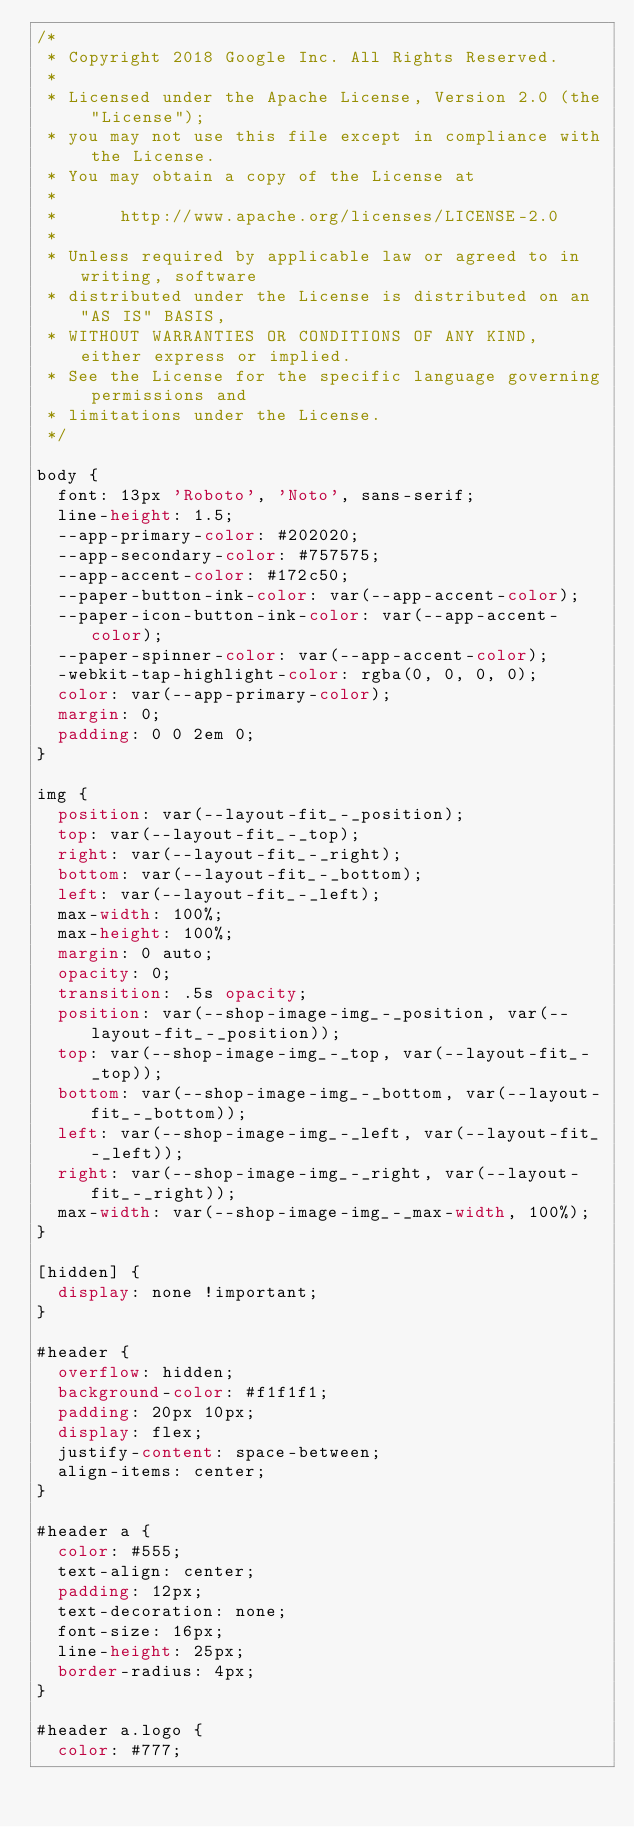<code> <loc_0><loc_0><loc_500><loc_500><_CSS_>/*
 * Copyright 2018 Google Inc. All Rights Reserved.
 *
 * Licensed under the Apache License, Version 2.0 (the "License");
 * you may not use this file except in compliance with the License.
 * You may obtain a copy of the License at
 *
 *      http://www.apache.org/licenses/LICENSE-2.0
 *
 * Unless required by applicable law or agreed to in writing, software
 * distributed under the License is distributed on an "AS IS" BASIS,
 * WITHOUT WARRANTIES OR CONDITIONS OF ANY KIND, either express or implied.
 * See the License for the specific language governing permissions and
 * limitations under the License.
 */

body {
  font: 13px 'Roboto', 'Noto', sans-serif;
  line-height: 1.5;
  --app-primary-color: #202020;
  --app-secondary-color: #757575;
  --app-accent-color: #172c50;
  --paper-button-ink-color: var(--app-accent-color);
  --paper-icon-button-ink-color: var(--app-accent-color);
  --paper-spinner-color: var(--app-accent-color);
  -webkit-tap-highlight-color: rgba(0, 0, 0, 0);
  color: var(--app-primary-color);
  margin: 0;
  padding: 0 0 2em 0;
}

img {
  position: var(--layout-fit_-_position);
  top: var(--layout-fit_-_top);
  right: var(--layout-fit_-_right);
  bottom: var(--layout-fit_-_bottom);
  left: var(--layout-fit_-_left);
  max-width: 100%;
  max-height: 100%;
  margin: 0 auto;
  opacity: 0;
  transition: .5s opacity;
  position: var(--shop-image-img_-_position, var(--layout-fit_-_position));
  top: var(--shop-image-img_-_top, var(--layout-fit_-_top));
  bottom: var(--shop-image-img_-_bottom, var(--layout-fit_-_bottom));
  left: var(--shop-image-img_-_left, var(--layout-fit_-_left));
  right: var(--shop-image-img_-_right, var(--layout-fit_-_right));
  max-width: var(--shop-image-img_-_max-width, 100%);
}

[hidden] {
  display: none !important;
}

#header {
  overflow: hidden;
  background-color: #f1f1f1;
  padding: 20px 10px;
  display: flex;
  justify-content: space-between;
  align-items: center;
}

#header a {
  color: #555;
  text-align: center;
  padding: 12px;
  text-decoration: none;
  font-size: 16px;
  line-height: 25px;
  border-radius: 4px;
}

#header a.logo {
  color: #777;</code> 